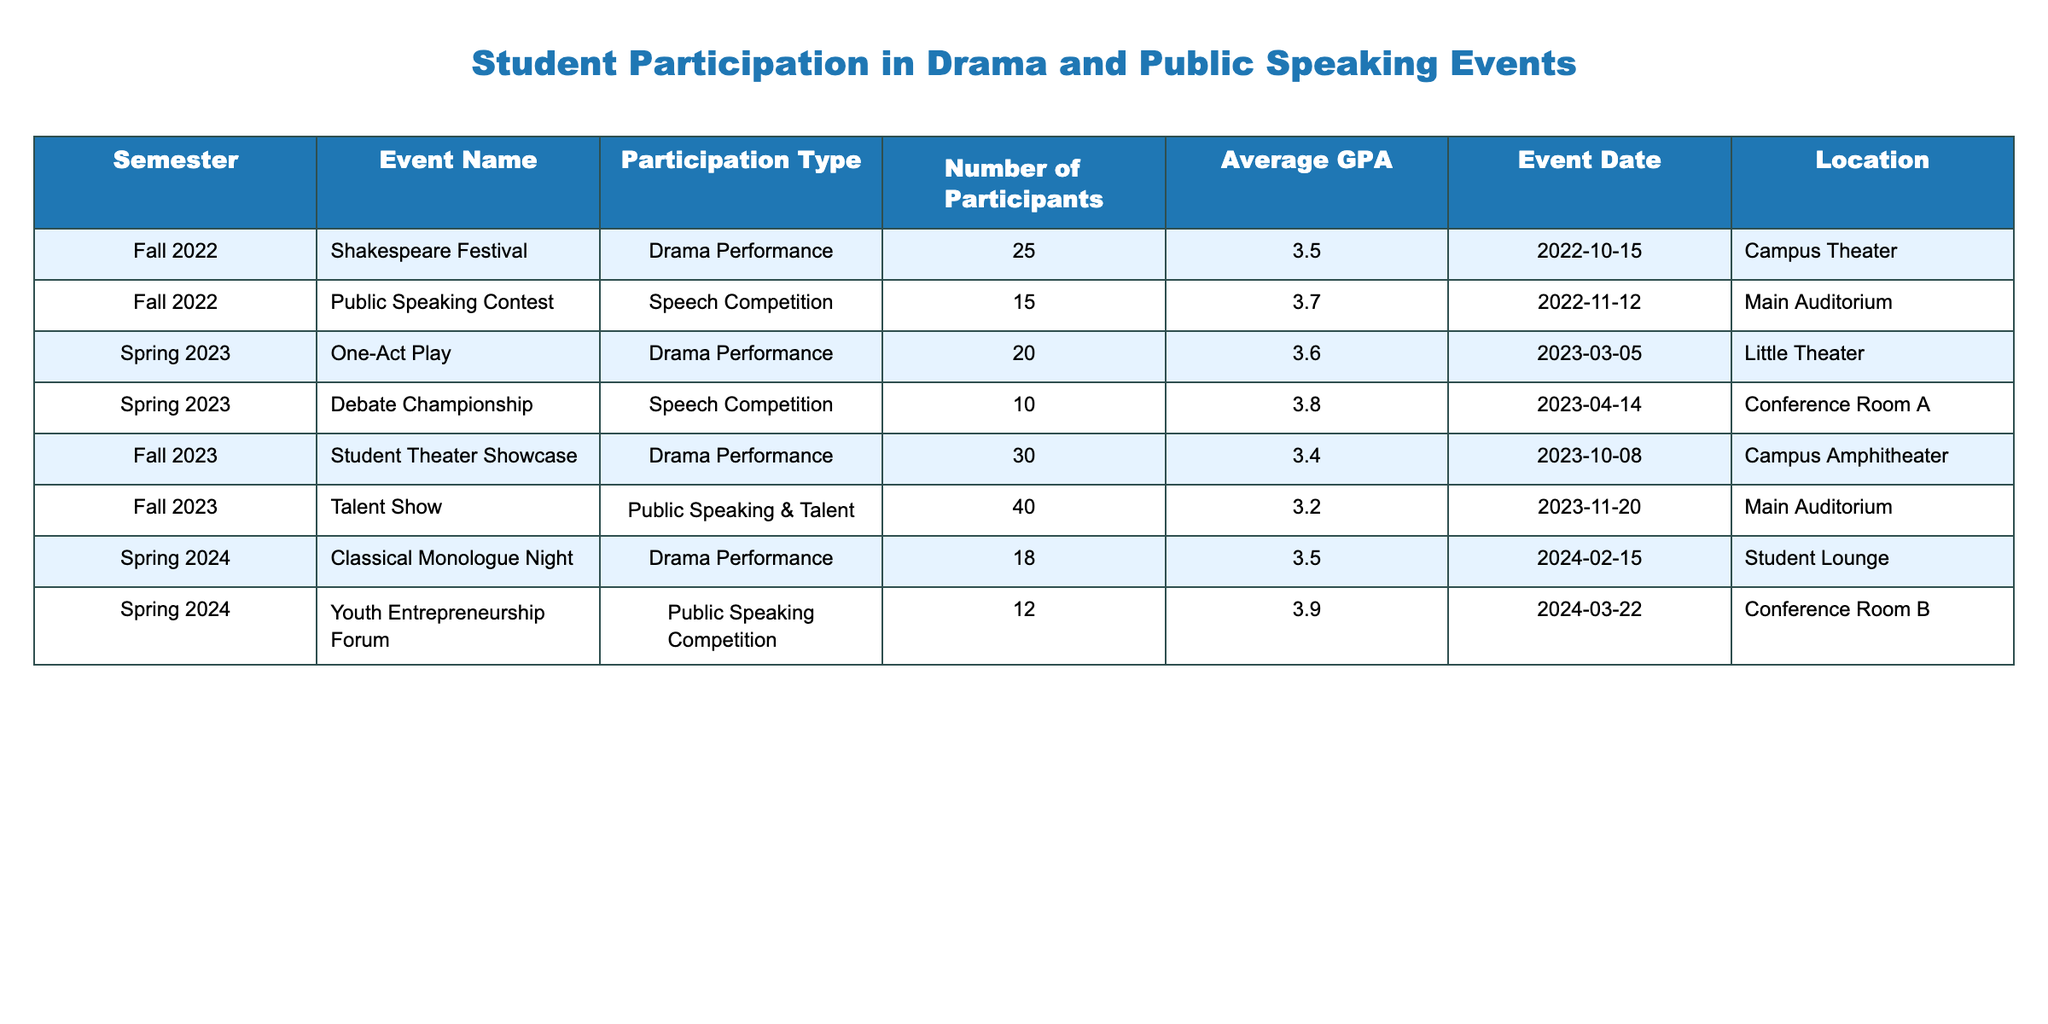What was the average GPA of participants in the Fall 2022 events? In Fall 2022, the two events were the Shakespeare Festival with an average GPA of 3.5 and the Public Speaking Contest with an average GPA of 3.7. To find the overall average GPA for that semester, sum the individual GPAs (3.5 + 3.7 = 7.2) and divide by the number of events (2), which gives 7.2 / 2 = 3.6.
Answer: 3.6 How many participants were involved in the Talent Show in Fall 2023? The table indicates that the Talent Show had 40 participants. This information can be directly read from the corresponding row in the table.
Answer: 40 Did the Debate Championship have more participants than the One-Act Play? The Debate Championship had 10 participants while the One-Act Play had 20 participants. Since 10 is less than 20, the answer is no.
Answer: No Which event had the highest number of participants across all semesters? The Talent Show in Fall 2023 had the highest number of participants, totaling 40. By comparing the total participants of each event listed, we see that 40 from the Talent Show is greater than all others (25, 15, 20, 10, 30, 18, 12).
Answer: Talent Show What is the total number of participants across all events in Spring 2024? In Spring 2024, there were two events: the Classical Monologue Night with 18 participants and the Youth Entrepreneurship Forum with 12 participants. Adding these together gives 18 + 12 = 30 participants total for Spring 2024.
Answer: 30 What is the average GPA of participants in drama performances? To find the average GPA of all drama performances, we need their individual GPAs: 3.5 (Shakespeare Festival), 3.6 (One-Act Play), 3.4 (Student Theater Showcase), and 3.5 (Classical Monologue Night). We first add these GPAs together (3.5 + 3.6 + 3.4 + 3.5 = 14.0) and divide by the number of events (4). The average GPA is 14.0 / 4 = 3.5.
Answer: 3.5 Did any event in Spring 2023 have an average GPA higher than 3.7? The events in Spring 2023 were the One-Act Play with 3.6 GPA and the Debate Championship with 3.8 GPA. Since 3.8 is greater than 3.7, it confirms that yes, one of the events exceeded that GPA.
Answer: Yes Which semester had the least number of participants in public speaking competitions? In Fall 2022, there were 15 participants in the Public Speaking Contest, while Spring 2024 had 12 participants in the Youth Entrepreneurship Forum. Since 12 is less than 15, Spring 2024 had the least number of participants in public speaking competitions.
Answer: Spring 2024 